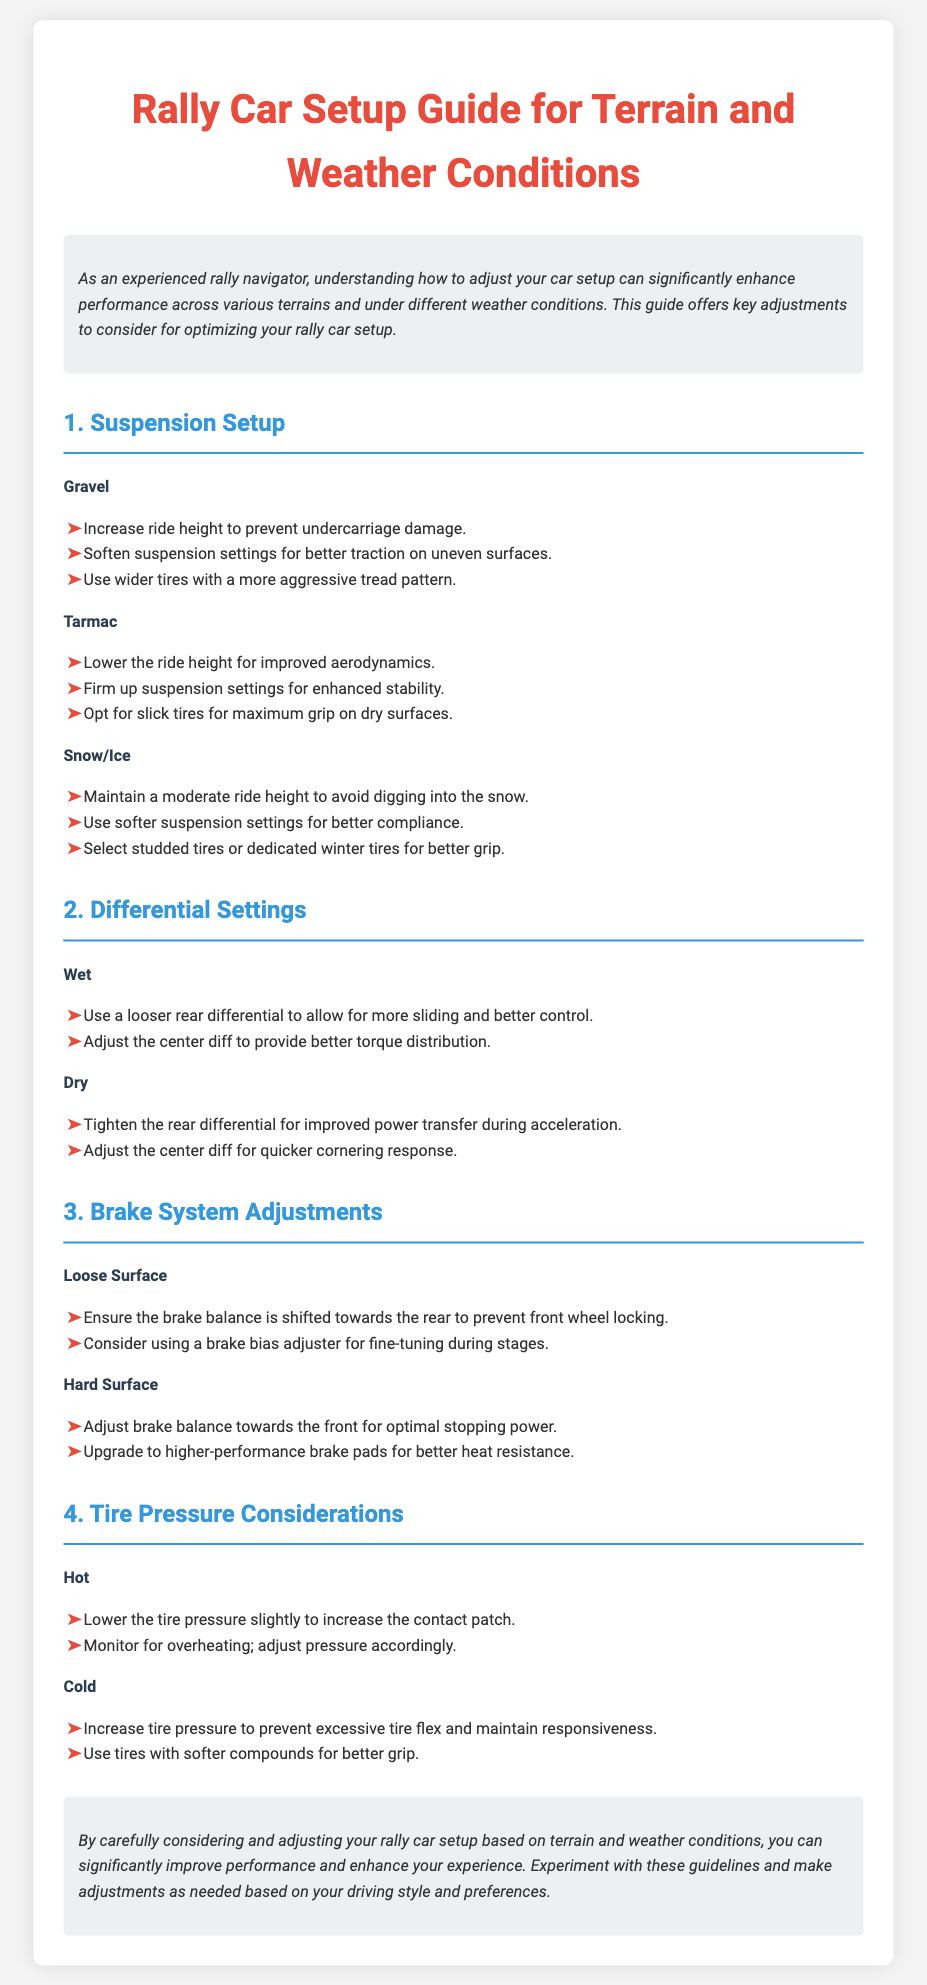What adjustments should be made for gravel terrain? The document lists specific adjustments for gravel terrain in the Suspension Setup section.
Answer: Increase ride height, soften suspension, wider tires What is the purpose of a brake bias adjuster? The document states that a brake bias adjuster is considered for fine-tuning during stages on loose surfaces.
Answer: Fine-tuning brake balance What tire option is recommended for snow or ice? The document specifies tire recommendations for snow or ice in the Suspension Setup section.
Answer: Studded tires or dedicated winter tires How should tire pressure be adjusted in hot weather? The document provides advice on tire pressure adjustments for hot weather in the Tire Pressure Considerations section.
Answer: Lower the tire pressure What should be done about the rear differential in wet conditions? The document details differential settings specifically for wet weather.
Answer: Use a looser rear differential What is the recommended tire type for dry tarmac surfaces? The document indicates preferred tire types in the Suspension Setup section for dry tarmac.
Answer: Slick tires 